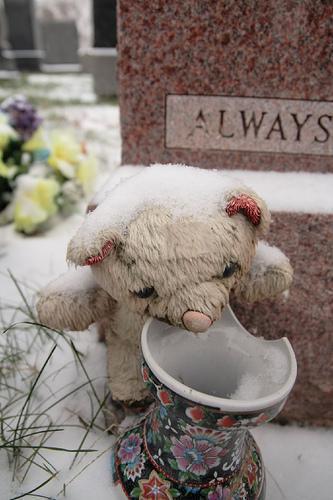How many items are placed on the gravestone?
Give a very brief answer. 2. How many people appear in this picture?
Give a very brief answer. 0. 